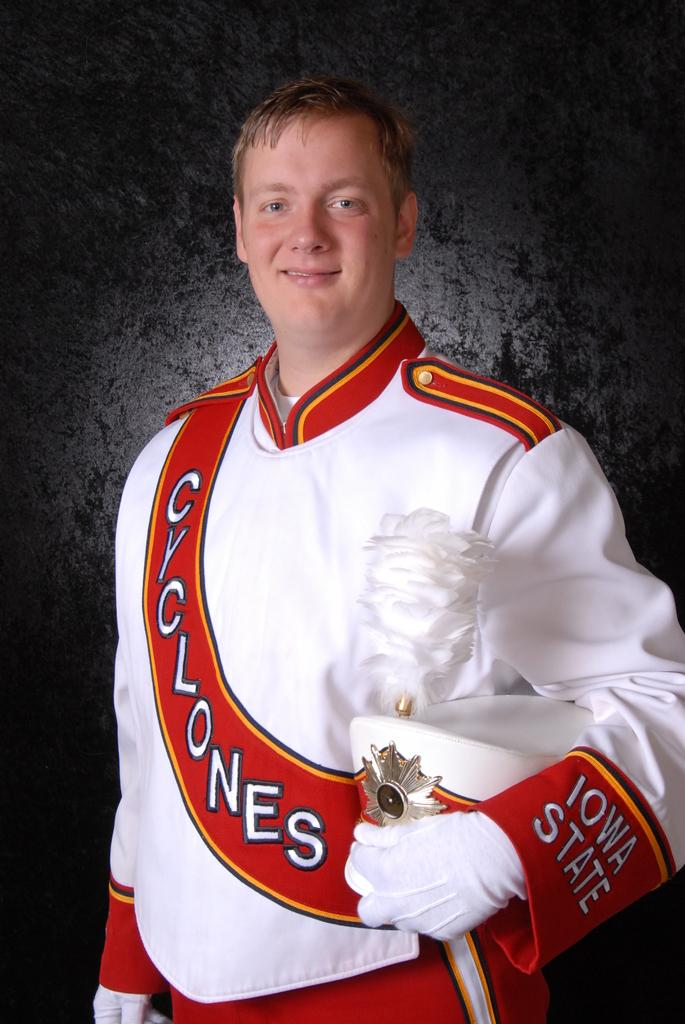<image>
Create a compact narrative representing the image presented. a man with cyclones written on his outfit and also a hat 